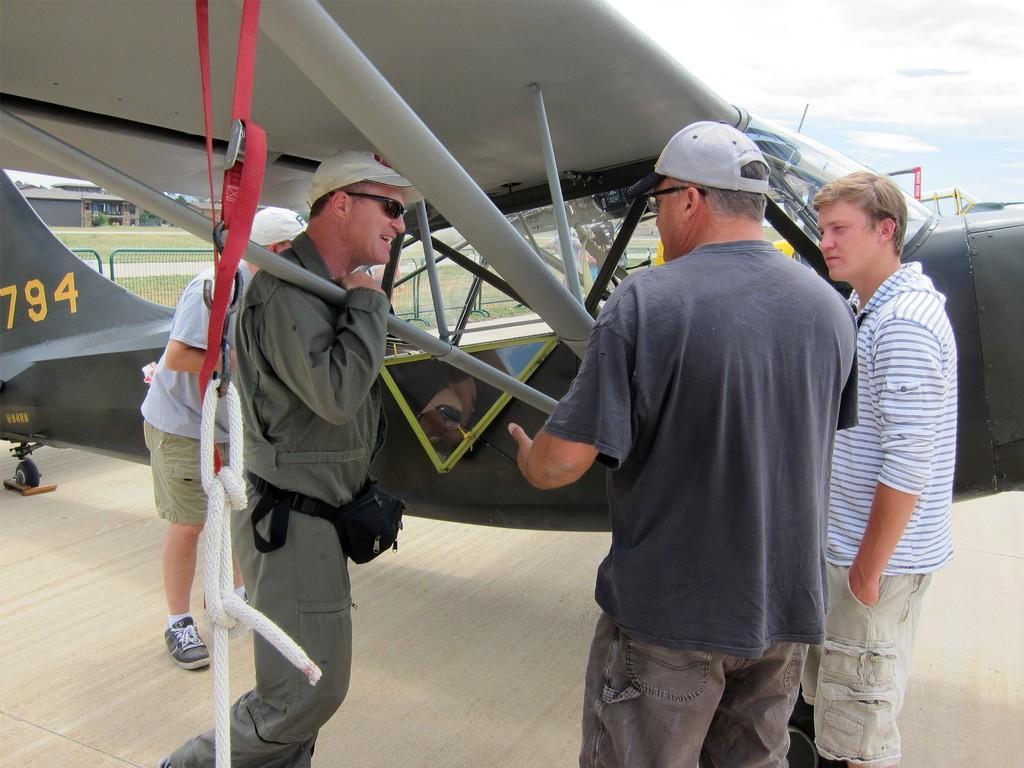Could you give a brief overview of what you see in this image? In this image we can see group of persons are standing on the ground, and smiling, in front here is the aircraft, here are the wings, at back here is the grass, at above here is the sky. 